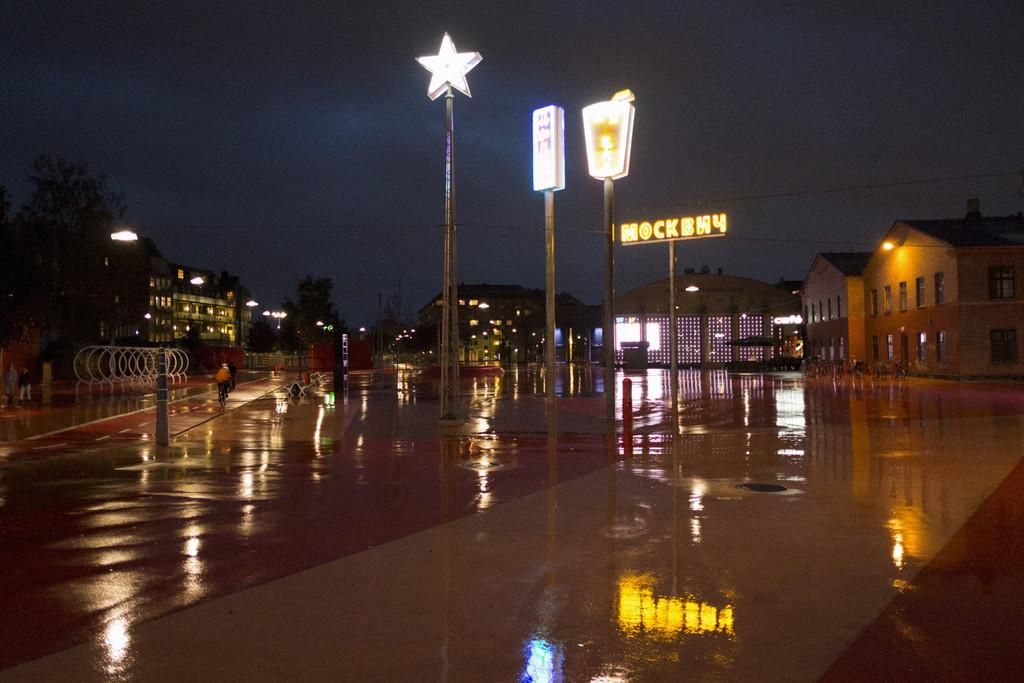What type of structures can be seen in the image? There are buildings in the image. What other natural elements are present in the image? There are trees in the image. What are the poles used for in the image? The poles have lights on them, suggesting they are used for illumination. What is the purpose of the board in the image? The presence of a board in the image suggests it might be used for displaying information or advertisements. What can be seen in the background of the image? The sky and people are visible in the background of the image. Can you see a sack being carried by someone in the image? There is no sack visible in the image, nor is anyone carrying a sack. What type of show is being performed in the image? There is no show or performance taking place in the image. 